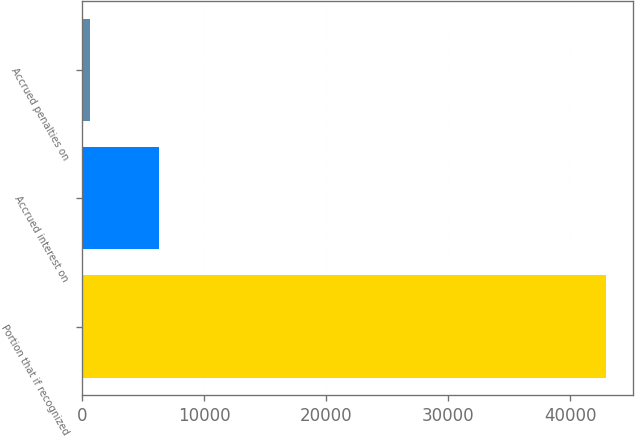Convert chart. <chart><loc_0><loc_0><loc_500><loc_500><bar_chart><fcel>Portion that if recognized<fcel>Accrued interest on<fcel>Accrued penalties on<nl><fcel>42952<fcel>6304<fcel>697<nl></chart> 